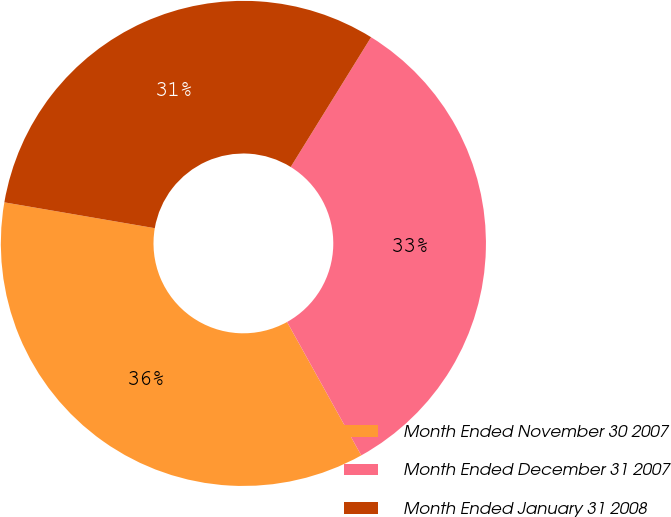Convert chart to OTSL. <chart><loc_0><loc_0><loc_500><loc_500><pie_chart><fcel>Month Ended November 30 2007<fcel>Month Ended December 31 2007<fcel>Month Ended January 31 2008<nl><fcel>35.79%<fcel>33.1%<fcel>31.12%<nl></chart> 